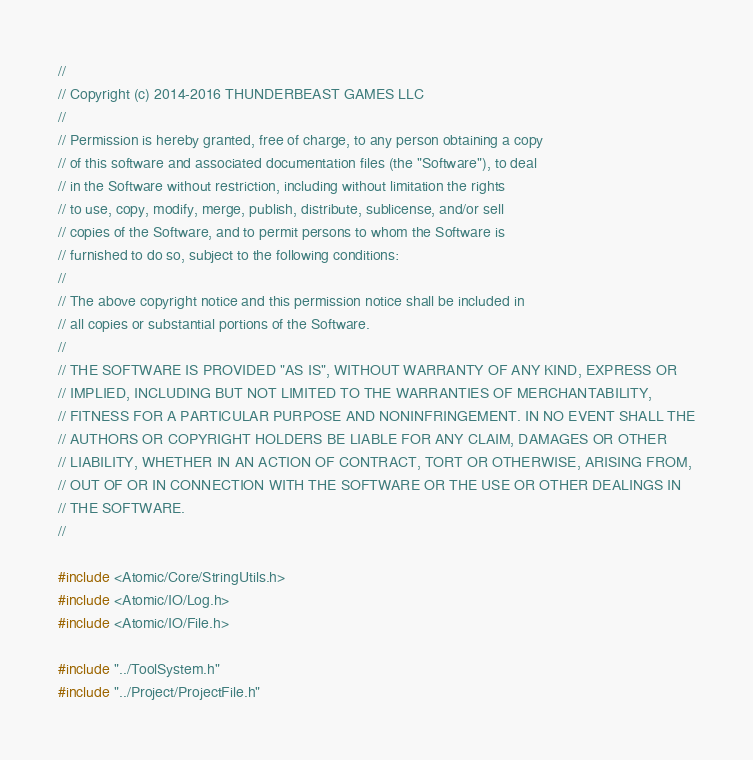<code> <loc_0><loc_0><loc_500><loc_500><_C++_>//
// Copyright (c) 2014-2016 THUNDERBEAST GAMES LLC
//
// Permission is hereby granted, free of charge, to any person obtaining a copy
// of this software and associated documentation files (the "Software"), to deal
// in the Software without restriction, including without limitation the rights
// to use, copy, modify, merge, publish, distribute, sublicense, and/or sell
// copies of the Software, and to permit persons to whom the Software is
// furnished to do so, subject to the following conditions:
//
// The above copyright notice and this permission notice shall be included in
// all copies or substantial portions of the Software.
//
// THE SOFTWARE IS PROVIDED "AS IS", WITHOUT WARRANTY OF ANY KIND, EXPRESS OR
// IMPLIED, INCLUDING BUT NOT LIMITED TO THE WARRANTIES OF MERCHANTABILITY,
// FITNESS FOR A PARTICULAR PURPOSE AND NONINFRINGEMENT. IN NO EVENT SHALL THE
// AUTHORS OR COPYRIGHT HOLDERS BE LIABLE FOR ANY CLAIM, DAMAGES OR OTHER
// LIABILITY, WHETHER IN AN ACTION OF CONTRACT, TORT OR OTHERWISE, ARISING FROM,
// OUT OF OR IN CONNECTION WITH THE SOFTWARE OR THE USE OR OTHER DEALINGS IN
// THE SOFTWARE.
//

#include <Atomic/Core/StringUtils.h>
#include <Atomic/IO/Log.h>
#include <Atomic/IO/File.h>

#include "../ToolSystem.h"
#include "../Project/ProjectFile.h"
</code> 